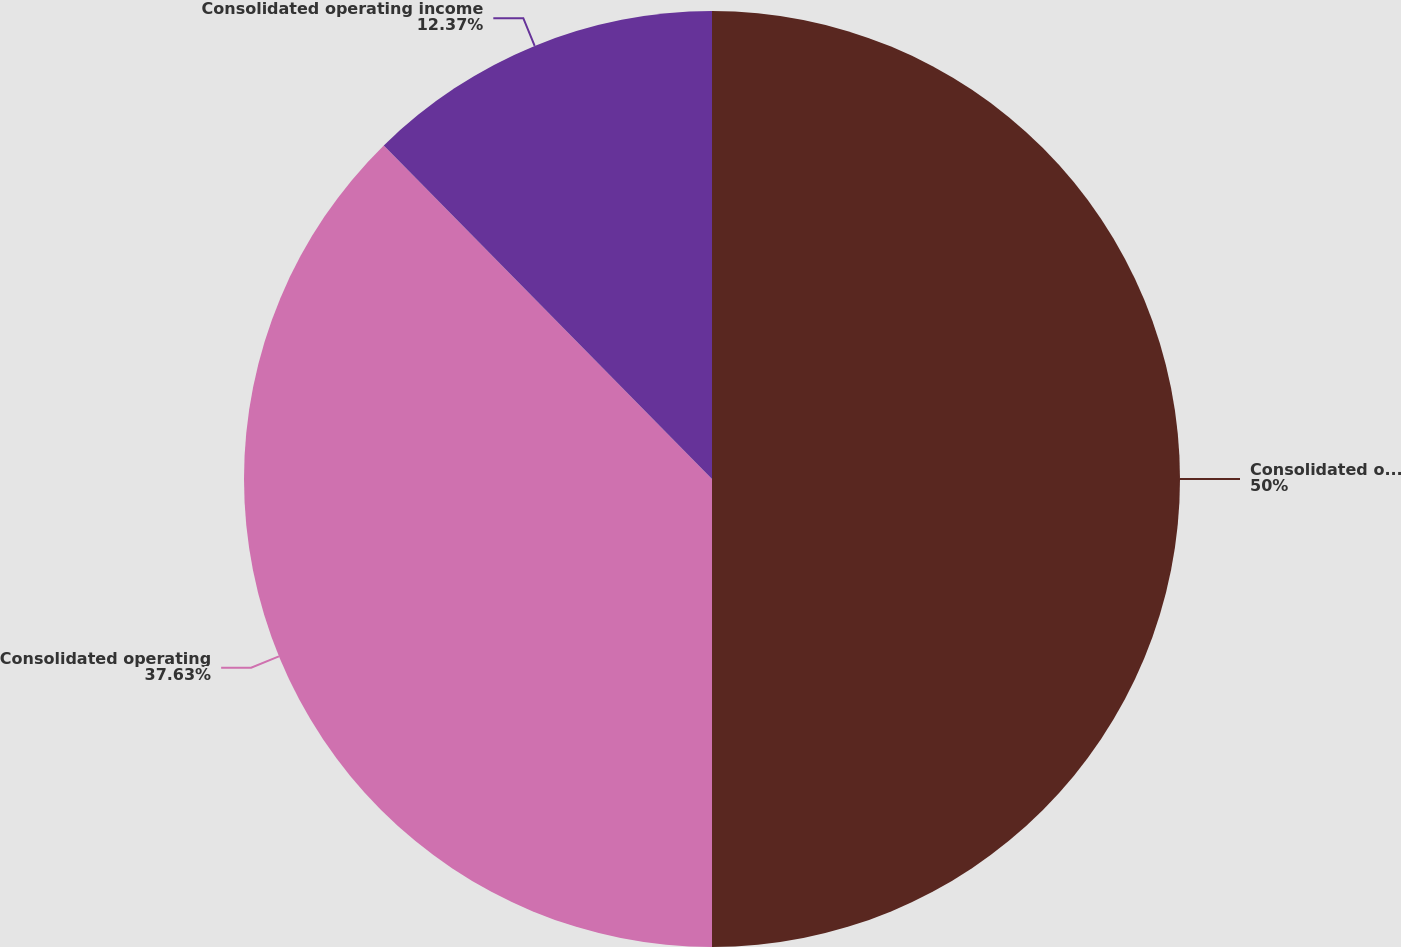Convert chart to OTSL. <chart><loc_0><loc_0><loc_500><loc_500><pie_chart><fcel>Consolidated operating revenue<fcel>Consolidated operating<fcel>Consolidated operating income<nl><fcel>50.0%<fcel>37.63%<fcel>12.37%<nl></chart> 